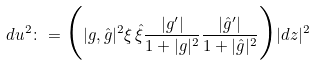<formula> <loc_0><loc_0><loc_500><loc_500>d u ^ { 2 } \colon = \Big { ( } | g , \hat { g } | ^ { 2 } \xi \, \hat { \xi } \frac { | g ^ { \prime } | } { 1 + | g | ^ { 2 } } \frac { | \hat { g } ^ { \prime } | } { 1 + | \hat { g } | ^ { 2 } } \Big { ) } | d z | ^ { 2 }</formula> 